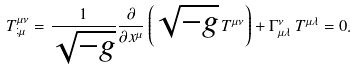Convert formula to latex. <formula><loc_0><loc_0><loc_500><loc_500>T _ { ; \mu } ^ { \mu \nu } = \frac { 1 } { \sqrt { - g } } \frac { \partial } { \partial x ^ { \mu } } \left ( \sqrt { - g } \, T ^ { \mu \nu } \right ) + \Gamma _ { \mu \lambda } ^ { \nu } \, T ^ { \mu \lambda } = 0 .</formula> 